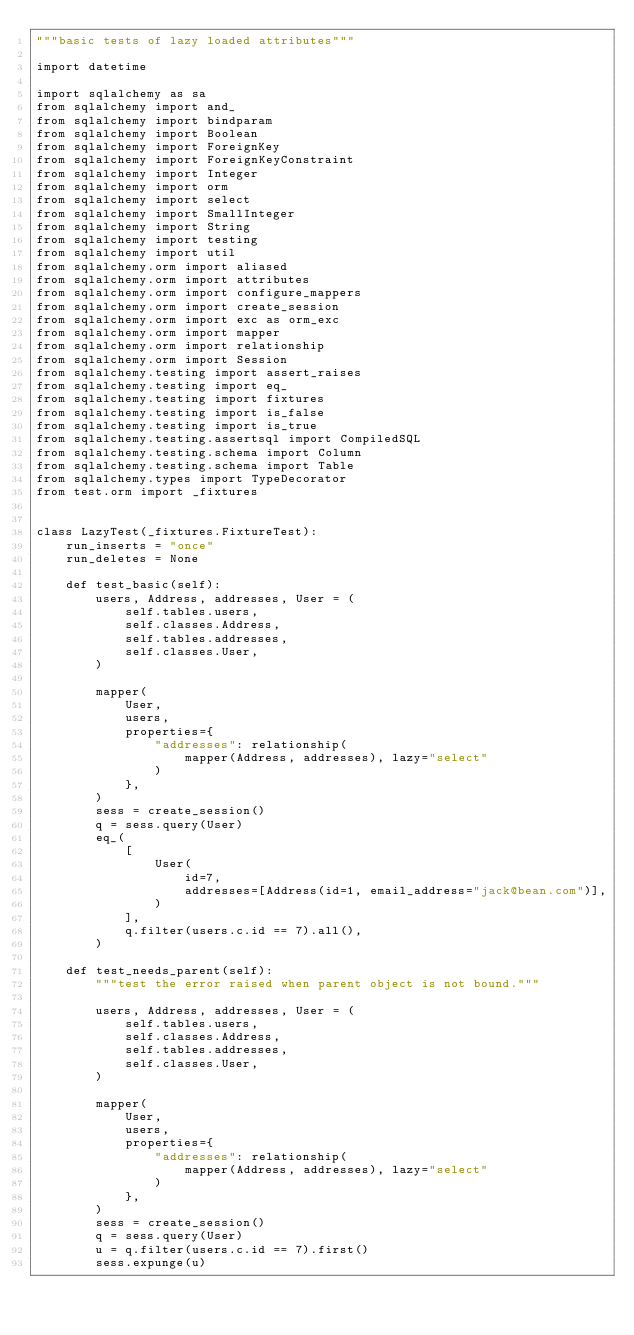<code> <loc_0><loc_0><loc_500><loc_500><_Python_>"""basic tests of lazy loaded attributes"""

import datetime

import sqlalchemy as sa
from sqlalchemy import and_
from sqlalchemy import bindparam
from sqlalchemy import Boolean
from sqlalchemy import ForeignKey
from sqlalchemy import ForeignKeyConstraint
from sqlalchemy import Integer
from sqlalchemy import orm
from sqlalchemy import select
from sqlalchemy import SmallInteger
from sqlalchemy import String
from sqlalchemy import testing
from sqlalchemy import util
from sqlalchemy.orm import aliased
from sqlalchemy.orm import attributes
from sqlalchemy.orm import configure_mappers
from sqlalchemy.orm import create_session
from sqlalchemy.orm import exc as orm_exc
from sqlalchemy.orm import mapper
from sqlalchemy.orm import relationship
from sqlalchemy.orm import Session
from sqlalchemy.testing import assert_raises
from sqlalchemy.testing import eq_
from sqlalchemy.testing import fixtures
from sqlalchemy.testing import is_false
from sqlalchemy.testing import is_true
from sqlalchemy.testing.assertsql import CompiledSQL
from sqlalchemy.testing.schema import Column
from sqlalchemy.testing.schema import Table
from sqlalchemy.types import TypeDecorator
from test.orm import _fixtures


class LazyTest(_fixtures.FixtureTest):
    run_inserts = "once"
    run_deletes = None

    def test_basic(self):
        users, Address, addresses, User = (
            self.tables.users,
            self.classes.Address,
            self.tables.addresses,
            self.classes.User,
        )

        mapper(
            User,
            users,
            properties={
                "addresses": relationship(
                    mapper(Address, addresses), lazy="select"
                )
            },
        )
        sess = create_session()
        q = sess.query(User)
        eq_(
            [
                User(
                    id=7,
                    addresses=[Address(id=1, email_address="jack@bean.com")],
                )
            ],
            q.filter(users.c.id == 7).all(),
        )

    def test_needs_parent(self):
        """test the error raised when parent object is not bound."""

        users, Address, addresses, User = (
            self.tables.users,
            self.classes.Address,
            self.tables.addresses,
            self.classes.User,
        )

        mapper(
            User,
            users,
            properties={
                "addresses": relationship(
                    mapper(Address, addresses), lazy="select"
                )
            },
        )
        sess = create_session()
        q = sess.query(User)
        u = q.filter(users.c.id == 7).first()
        sess.expunge(u)</code> 